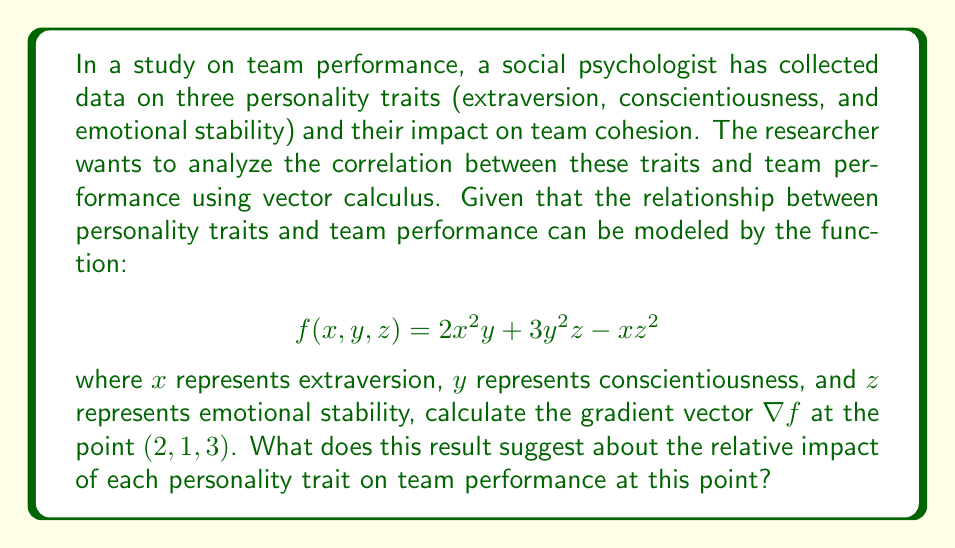Can you answer this question? To solve this problem, we need to follow these steps:

1. Understand the function:
   The given function $f(x, y, z) = 2x^2y + 3y^2z - xz^2$ represents the relationship between personality traits and team performance.

2. Calculate the gradient vector:
   The gradient vector $\nabla f$ is defined as:
   $$\nabla f = \left(\frac{\partial f}{\partial x}, \frac{\partial f}{\partial y}, \frac{\partial f}{\partial z}\right)$$

   Let's calculate each partial derivative:

   a) $\frac{\partial f}{\partial x} = 4xy - z^2$
   b) $\frac{\partial f}{\partial y} = 2x^2 + 6yz$
   c) $\frac{\partial f}{\partial z} = 3y^2 - 2xz$

3. Evaluate the gradient at the point $(2, 1, 3)$:
   
   a) $\frac{\partial f}{\partial x}|_{(2,1,3)} = 4(2)(1) - 3^2 = 8 - 9 = -1$
   b) $\frac{\partial f}{\partial y}|_{(2,1,3)} = 2(2^2) + 6(1)(3) = 8 + 18 = 26$
   c) $\frac{\partial f}{\partial z}|_{(2,1,3)} = 3(1^2) - 2(2)(3) = 3 - 12 = -9$

4. Construct the gradient vector:
   $$\nabla f|_{(2,1,3)} = (-1, 26, -9)$$

5. Interpret the result:
   The gradient vector represents the direction of steepest increase in the function at the given point. The magnitude of each component indicates the rate of change in that direction.

   - The negative value for extraversion (-1) suggests a slight negative impact on team performance at this point.
   - The large positive value for conscientiousness (26) indicates a strong positive impact on team performance.
   - The negative value for emotional stability (-9) suggests a moderate negative impact on team performance.
Answer: The gradient vector at the point (2, 1, 3) is $\nabla f|_{(2,1,3)} = (-1, 26, -9)$. This result suggests that at this point, conscientiousness has the strongest positive impact on team performance, emotional stability has a moderate negative impact, and extraversion has a slight negative impact. 